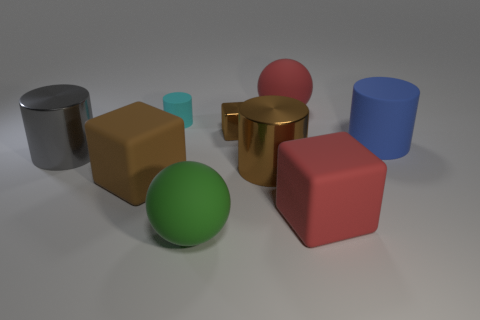Subtract all brown cylinders. How many cylinders are left? 3 Subtract all cyan cylinders. How many brown blocks are left? 2 Subtract all gray cylinders. How many cylinders are left? 3 Subtract all purple cylinders. Subtract all gray spheres. How many cylinders are left? 4 Add 1 large rubber blocks. How many objects exist? 10 Subtract all cylinders. How many objects are left? 5 Subtract 0 green cylinders. How many objects are left? 9 Subtract all big objects. Subtract all large red metallic objects. How many objects are left? 2 Add 4 large green rubber things. How many large green rubber things are left? 5 Add 5 red blocks. How many red blocks exist? 6 